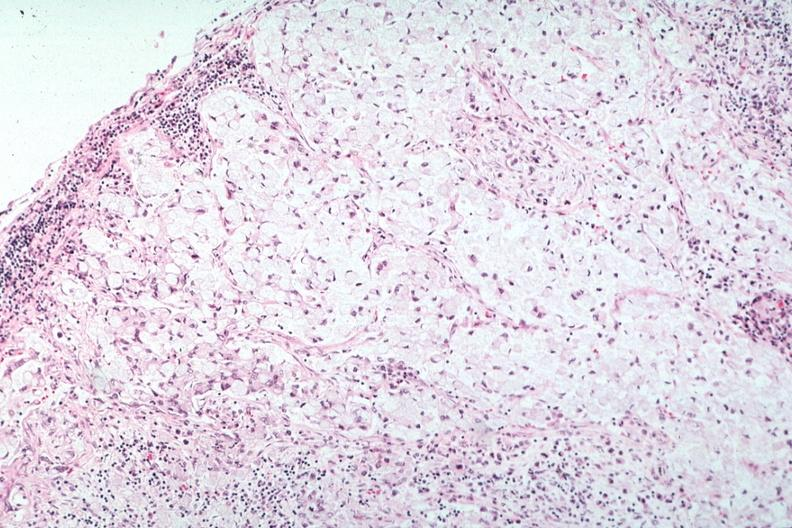s metastatic carcinoma present?
Answer the question using a single word or phrase. Yes 